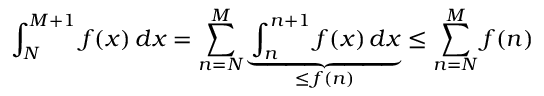<formula> <loc_0><loc_0><loc_500><loc_500>\int _ { N } ^ { M + 1 } f ( x ) \, d x = \sum _ { n = N } ^ { M } \underbrace { \int _ { n } ^ { n + 1 } f ( x ) \, d x } _ { \leq \, f ( n ) } \leq \sum _ { n = N } ^ { M } f ( n )</formula> 